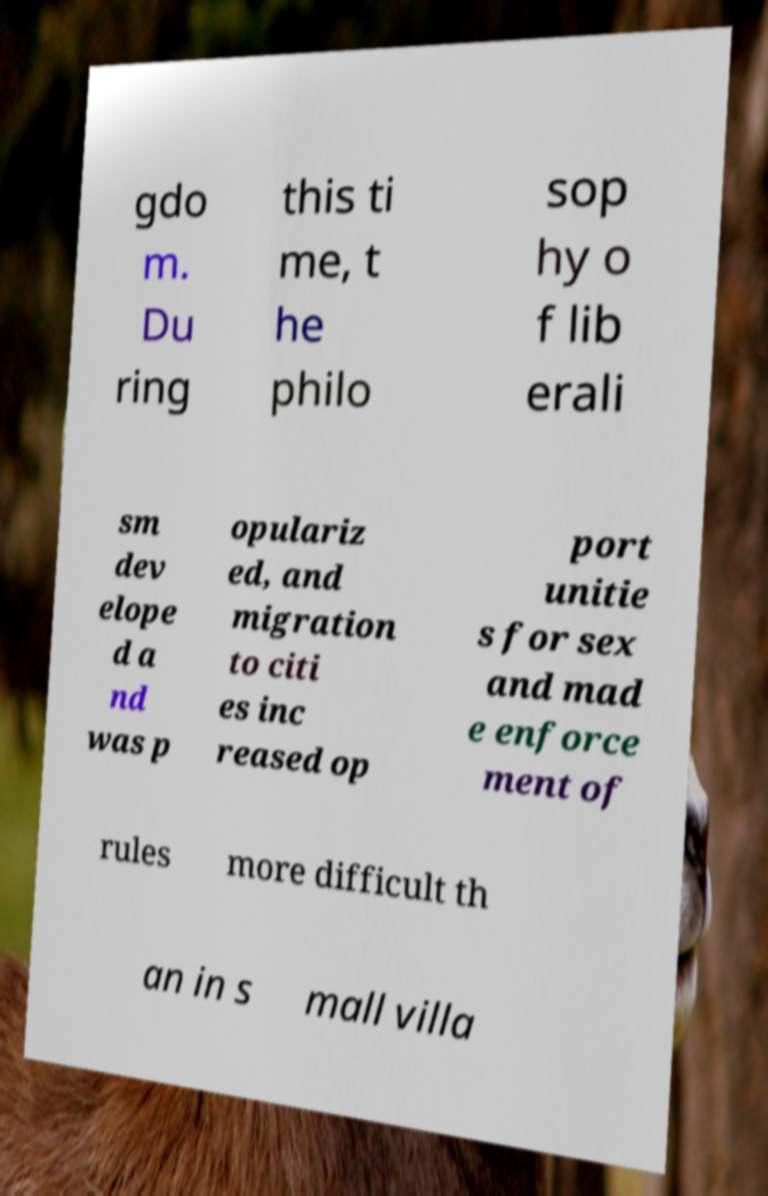There's text embedded in this image that I need extracted. Can you transcribe it verbatim? gdo m. Du ring this ti me, t he philo sop hy o f lib erali sm dev elope d a nd was p opulariz ed, and migration to citi es inc reased op port unitie s for sex and mad e enforce ment of rules more difficult th an in s mall villa 